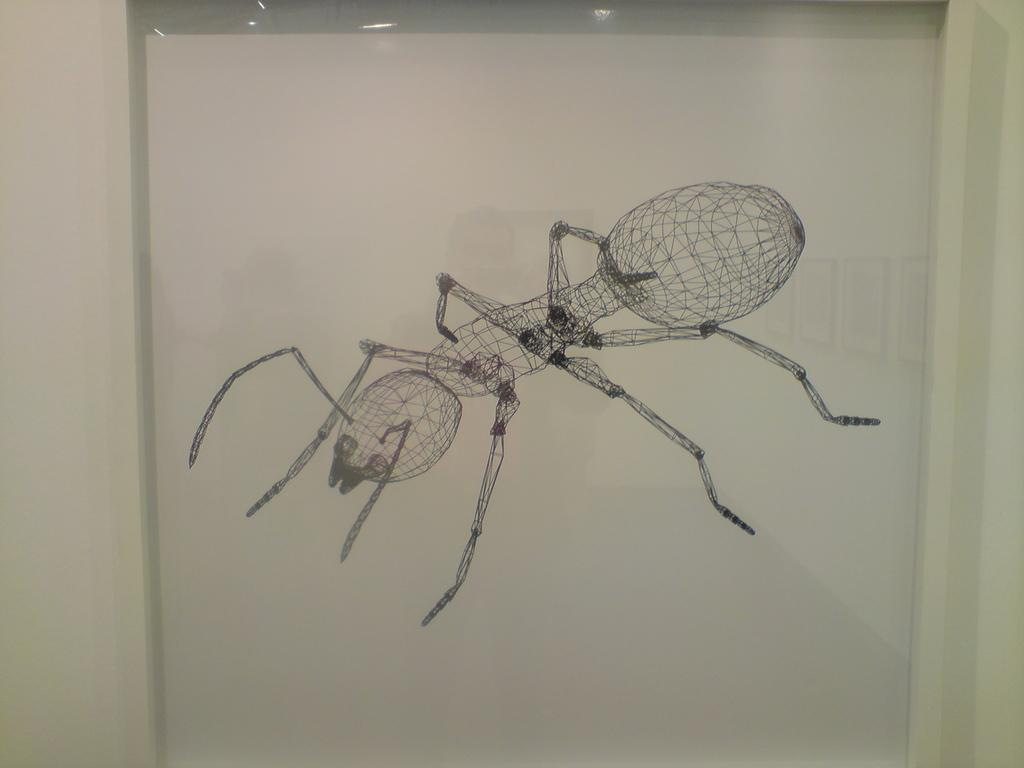What is depicted on the poster in the image? There is an outline of an ant on a poster in the image. What type of flower is growing near the arch in the image? There is no arch or flower present in the image; it only features an outline of an ant on a poster. 